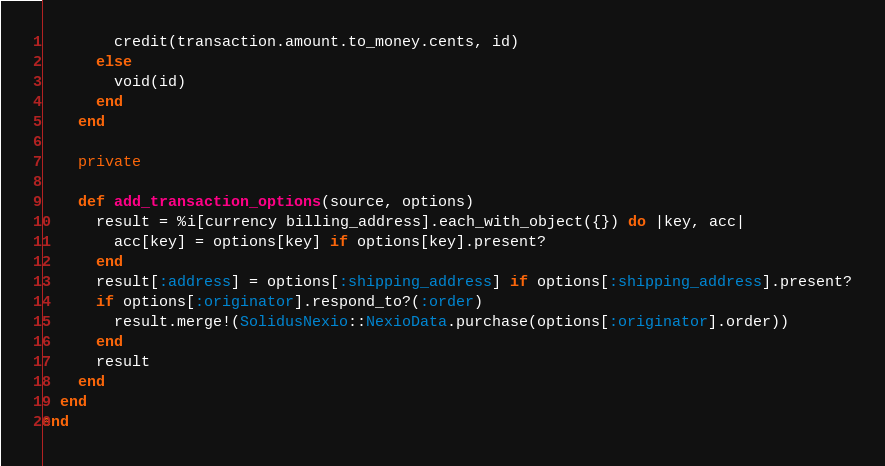<code> <loc_0><loc_0><loc_500><loc_500><_Ruby_>        credit(transaction.amount.to_money.cents, id)
      else
        void(id)
      end
    end

    private

    def add_transaction_options(source, options)
      result = %i[currency billing_address].each_with_object({}) do |key, acc|
        acc[key] = options[key] if options[key].present?
      end
      result[:address] = options[:shipping_address] if options[:shipping_address].present?
      if options[:originator].respond_to?(:order)
        result.merge!(SolidusNexio::NexioData.purchase(options[:originator].order))
      end
      result
    end
  end
end
</code> 